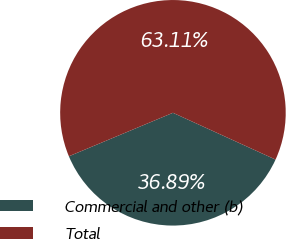<chart> <loc_0><loc_0><loc_500><loc_500><pie_chart><fcel>Commercial and other (b)<fcel>Total<nl><fcel>36.89%<fcel>63.11%<nl></chart> 